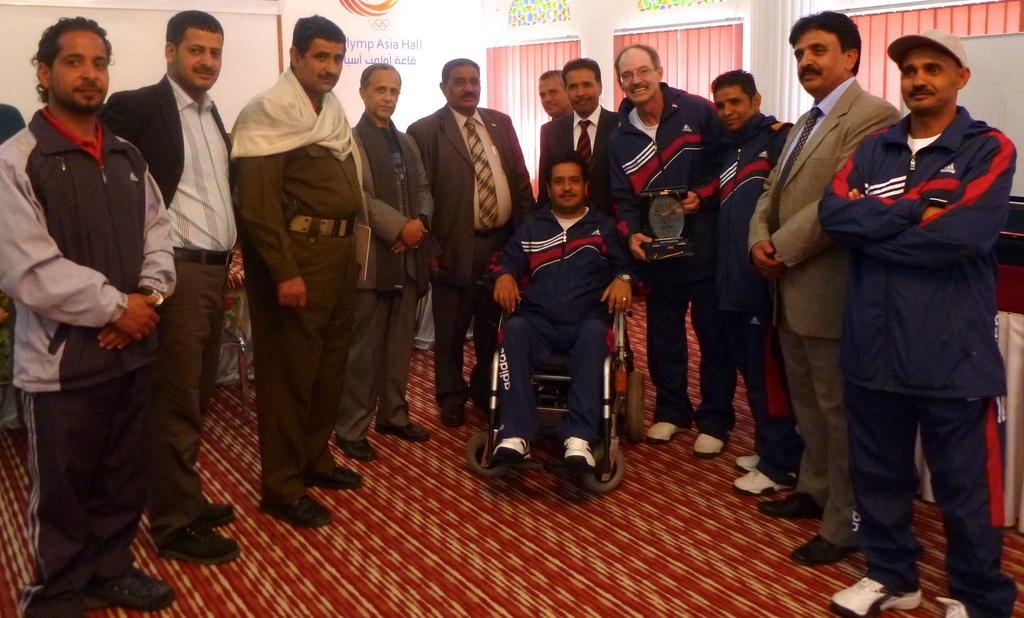Could you give a brief overview of what you see in this image? In this image, we can see persons standing and wearing clothes. There is a person in the middle of the image sitting on the wheelchair. 